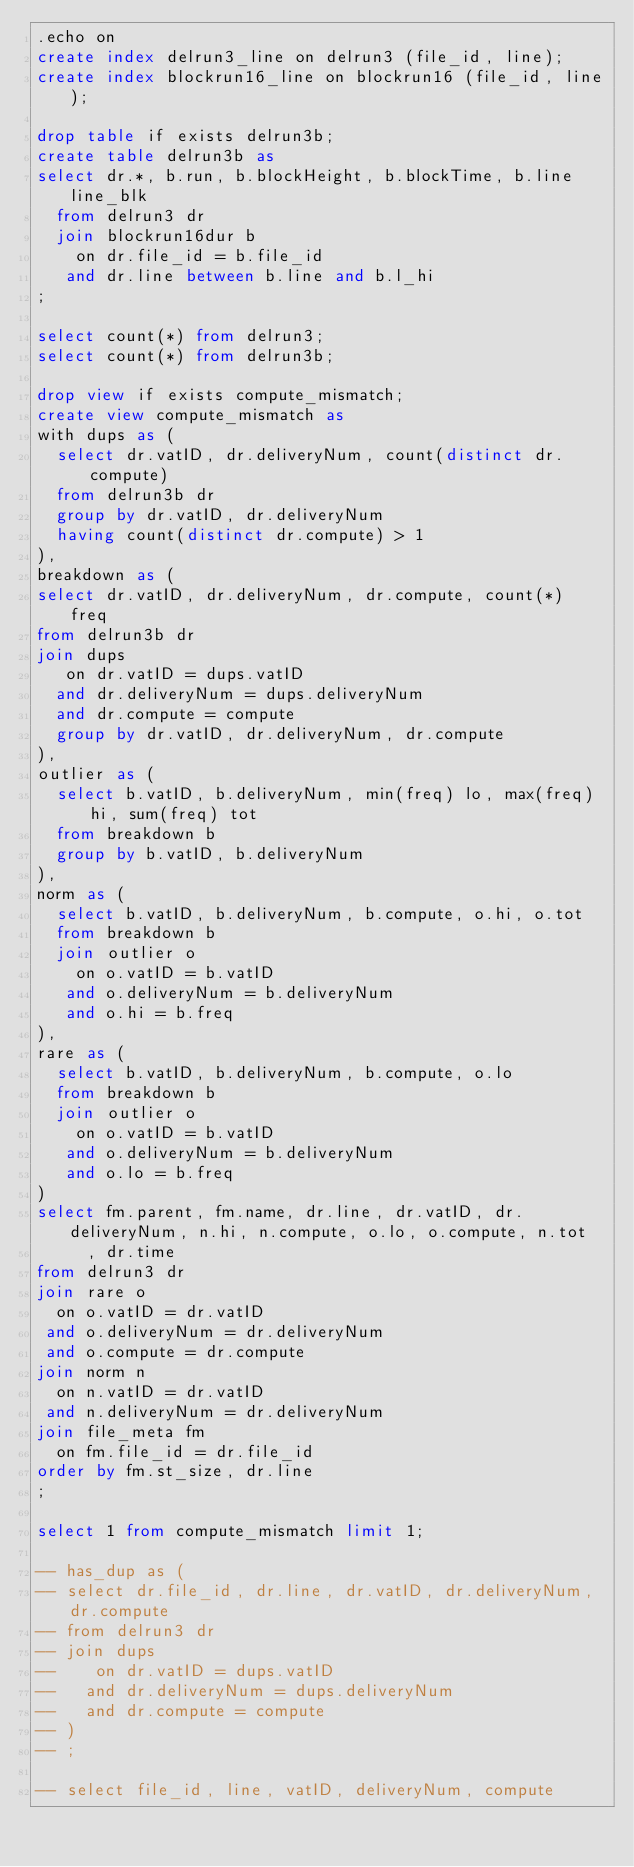<code> <loc_0><loc_0><loc_500><loc_500><_SQL_>.echo on
create index delrun3_line on delrun3 (file_id, line);
create index blockrun16_line on blockrun16 (file_id, line);

drop table if exists delrun3b;
create table delrun3b as
select dr.*, b.run, b.blockHeight, b.blockTime, b.line line_blk
  from delrun3 dr
  join blockrun16dur b
    on dr.file_id = b.file_id
   and dr.line between b.line and b.l_hi
;

select count(*) from delrun3;
select count(*) from delrun3b;

drop view if exists compute_mismatch;
create view compute_mismatch as
with dups as (
  select dr.vatID, dr.deliveryNum, count(distinct dr.compute)
  from delrun3b dr
  group by dr.vatID, dr.deliveryNum
  having count(distinct dr.compute) > 1
),
breakdown as (
select dr.vatID, dr.deliveryNum, dr.compute, count(*) freq
from delrun3b dr
join dups
   on dr.vatID = dups.vatID
  and dr.deliveryNum = dups.deliveryNum
  and dr.compute = compute
  group by dr.vatID, dr.deliveryNum, dr.compute
),
outlier as (
  select b.vatID, b.deliveryNum, min(freq) lo, max(freq) hi, sum(freq) tot
  from breakdown b
  group by b.vatID, b.deliveryNum
),
norm as (
  select b.vatID, b.deliveryNum, b.compute, o.hi, o.tot
  from breakdown b
  join outlier o
    on o.vatID = b.vatID
   and o.deliveryNum = b.deliveryNum
   and o.hi = b.freq
),
rare as (
  select b.vatID, b.deliveryNum, b.compute, o.lo
  from breakdown b
  join outlier o
    on o.vatID = b.vatID
   and o.deliveryNum = b.deliveryNum
   and o.lo = b.freq
)
select fm.parent, fm.name, dr.line, dr.vatID, dr.deliveryNum, n.hi, n.compute, o.lo, o.compute, n.tot
     , dr.time
from delrun3 dr
join rare o
  on o.vatID = dr.vatID
 and o.deliveryNum = dr.deliveryNum
 and o.compute = dr.compute
join norm n
  on n.vatID = dr.vatID
 and n.deliveryNum = dr.deliveryNum
join file_meta fm
  on fm.file_id = dr.file_id
order by fm.st_size, dr.line
;

select 1 from compute_mismatch limit 1;

-- has_dup as (
-- select dr.file_id, dr.line, dr.vatID, dr.deliveryNum, dr.compute
-- from delrun3 dr
-- join dups
--    on dr.vatID = dups.vatID
--   and dr.deliveryNum = dups.deliveryNum
--   and dr.compute = compute
-- )
-- ;

-- select file_id, line, vatID, deliveryNum, compute
</code> 